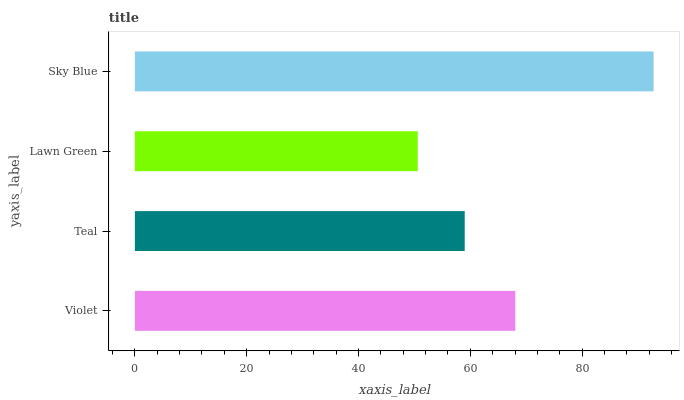Is Lawn Green the minimum?
Answer yes or no. Yes. Is Sky Blue the maximum?
Answer yes or no. Yes. Is Teal the minimum?
Answer yes or no. No. Is Teal the maximum?
Answer yes or no. No. Is Violet greater than Teal?
Answer yes or no. Yes. Is Teal less than Violet?
Answer yes or no. Yes. Is Teal greater than Violet?
Answer yes or no. No. Is Violet less than Teal?
Answer yes or no. No. Is Violet the high median?
Answer yes or no. Yes. Is Teal the low median?
Answer yes or no. Yes. Is Sky Blue the high median?
Answer yes or no. No. Is Lawn Green the low median?
Answer yes or no. No. 